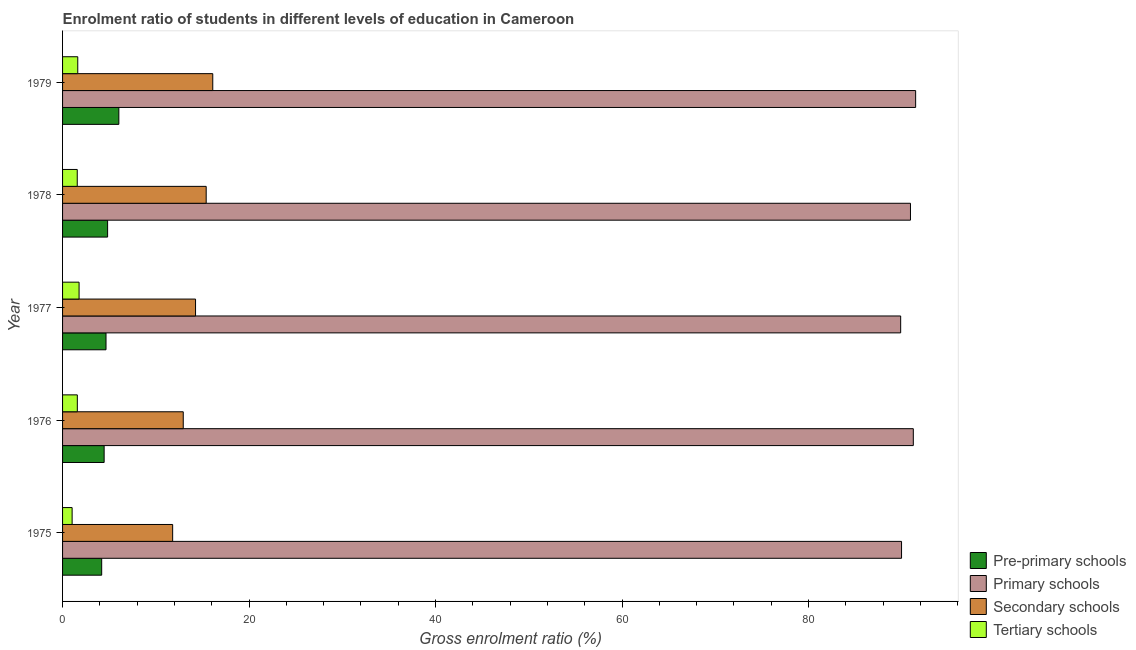How many groups of bars are there?
Provide a succinct answer. 5. Are the number of bars per tick equal to the number of legend labels?
Ensure brevity in your answer.  Yes. How many bars are there on the 4th tick from the top?
Offer a terse response. 4. What is the label of the 5th group of bars from the top?
Your answer should be very brief. 1975. In how many cases, is the number of bars for a given year not equal to the number of legend labels?
Ensure brevity in your answer.  0. What is the gross enrolment ratio in primary schools in 1977?
Your response must be concise. 89.88. Across all years, what is the maximum gross enrolment ratio in pre-primary schools?
Your response must be concise. 6.04. Across all years, what is the minimum gross enrolment ratio in primary schools?
Your answer should be very brief. 89.88. In which year was the gross enrolment ratio in pre-primary schools maximum?
Provide a succinct answer. 1979. In which year was the gross enrolment ratio in primary schools minimum?
Ensure brevity in your answer.  1977. What is the total gross enrolment ratio in secondary schools in the graph?
Provide a succinct answer. 70.52. What is the difference between the gross enrolment ratio in primary schools in 1977 and that in 1978?
Your answer should be very brief. -1.05. What is the difference between the gross enrolment ratio in primary schools in 1977 and the gross enrolment ratio in tertiary schools in 1975?
Your answer should be compact. 88.85. What is the average gross enrolment ratio in primary schools per year?
Provide a short and direct response. 90.7. In the year 1979, what is the difference between the gross enrolment ratio in primary schools and gross enrolment ratio in pre-primary schools?
Make the answer very short. 85.45. What is the ratio of the gross enrolment ratio in pre-primary schools in 1975 to that in 1977?
Ensure brevity in your answer.  0.9. What is the difference between the highest and the second highest gross enrolment ratio in primary schools?
Make the answer very short. 0.25. What is the difference between the highest and the lowest gross enrolment ratio in primary schools?
Provide a succinct answer. 1.61. In how many years, is the gross enrolment ratio in tertiary schools greater than the average gross enrolment ratio in tertiary schools taken over all years?
Offer a terse response. 4. Is it the case that in every year, the sum of the gross enrolment ratio in primary schools and gross enrolment ratio in pre-primary schools is greater than the sum of gross enrolment ratio in secondary schools and gross enrolment ratio in tertiary schools?
Your response must be concise. Yes. What does the 4th bar from the top in 1975 represents?
Your response must be concise. Pre-primary schools. What does the 3rd bar from the bottom in 1979 represents?
Make the answer very short. Secondary schools. Is it the case that in every year, the sum of the gross enrolment ratio in pre-primary schools and gross enrolment ratio in primary schools is greater than the gross enrolment ratio in secondary schools?
Offer a terse response. Yes. Are the values on the major ticks of X-axis written in scientific E-notation?
Your answer should be very brief. No. Where does the legend appear in the graph?
Provide a succinct answer. Bottom right. How many legend labels are there?
Offer a terse response. 4. How are the legend labels stacked?
Offer a very short reply. Vertical. What is the title of the graph?
Give a very brief answer. Enrolment ratio of students in different levels of education in Cameroon. What is the Gross enrolment ratio (%) of Pre-primary schools in 1975?
Offer a very short reply. 4.19. What is the Gross enrolment ratio (%) in Primary schools in 1975?
Provide a succinct answer. 89.97. What is the Gross enrolment ratio (%) of Secondary schools in 1975?
Keep it short and to the point. 11.81. What is the Gross enrolment ratio (%) in Tertiary schools in 1975?
Give a very brief answer. 1.03. What is the Gross enrolment ratio (%) of Pre-primary schools in 1976?
Your answer should be compact. 4.46. What is the Gross enrolment ratio (%) in Primary schools in 1976?
Offer a very short reply. 91.24. What is the Gross enrolment ratio (%) of Secondary schools in 1976?
Ensure brevity in your answer.  12.94. What is the Gross enrolment ratio (%) in Tertiary schools in 1976?
Provide a succinct answer. 1.58. What is the Gross enrolment ratio (%) in Pre-primary schools in 1977?
Give a very brief answer. 4.66. What is the Gross enrolment ratio (%) in Primary schools in 1977?
Give a very brief answer. 89.88. What is the Gross enrolment ratio (%) of Secondary schools in 1977?
Make the answer very short. 14.26. What is the Gross enrolment ratio (%) in Tertiary schools in 1977?
Offer a very short reply. 1.77. What is the Gross enrolment ratio (%) of Pre-primary schools in 1978?
Your answer should be very brief. 4.83. What is the Gross enrolment ratio (%) of Primary schools in 1978?
Keep it short and to the point. 90.93. What is the Gross enrolment ratio (%) of Secondary schools in 1978?
Offer a very short reply. 15.4. What is the Gross enrolment ratio (%) in Tertiary schools in 1978?
Offer a very short reply. 1.57. What is the Gross enrolment ratio (%) of Pre-primary schools in 1979?
Your response must be concise. 6.04. What is the Gross enrolment ratio (%) in Primary schools in 1979?
Provide a short and direct response. 91.48. What is the Gross enrolment ratio (%) in Secondary schools in 1979?
Provide a short and direct response. 16.11. What is the Gross enrolment ratio (%) of Tertiary schools in 1979?
Offer a very short reply. 1.63. Across all years, what is the maximum Gross enrolment ratio (%) of Pre-primary schools?
Make the answer very short. 6.04. Across all years, what is the maximum Gross enrolment ratio (%) of Primary schools?
Your answer should be very brief. 91.48. Across all years, what is the maximum Gross enrolment ratio (%) of Secondary schools?
Provide a succinct answer. 16.11. Across all years, what is the maximum Gross enrolment ratio (%) of Tertiary schools?
Your answer should be very brief. 1.77. Across all years, what is the minimum Gross enrolment ratio (%) of Pre-primary schools?
Offer a very short reply. 4.19. Across all years, what is the minimum Gross enrolment ratio (%) in Primary schools?
Offer a very short reply. 89.88. Across all years, what is the minimum Gross enrolment ratio (%) of Secondary schools?
Make the answer very short. 11.81. Across all years, what is the minimum Gross enrolment ratio (%) in Tertiary schools?
Make the answer very short. 1.03. What is the total Gross enrolment ratio (%) of Pre-primary schools in the graph?
Keep it short and to the point. 24.18. What is the total Gross enrolment ratio (%) in Primary schools in the graph?
Provide a short and direct response. 453.5. What is the total Gross enrolment ratio (%) in Secondary schools in the graph?
Offer a very short reply. 70.52. What is the total Gross enrolment ratio (%) of Tertiary schools in the graph?
Keep it short and to the point. 7.58. What is the difference between the Gross enrolment ratio (%) in Pre-primary schools in 1975 and that in 1976?
Ensure brevity in your answer.  -0.26. What is the difference between the Gross enrolment ratio (%) of Primary schools in 1975 and that in 1976?
Provide a succinct answer. -1.26. What is the difference between the Gross enrolment ratio (%) of Secondary schools in 1975 and that in 1976?
Your answer should be compact. -1.14. What is the difference between the Gross enrolment ratio (%) in Tertiary schools in 1975 and that in 1976?
Provide a succinct answer. -0.56. What is the difference between the Gross enrolment ratio (%) in Pre-primary schools in 1975 and that in 1977?
Offer a very short reply. -0.46. What is the difference between the Gross enrolment ratio (%) in Primary schools in 1975 and that in 1977?
Keep it short and to the point. 0.09. What is the difference between the Gross enrolment ratio (%) of Secondary schools in 1975 and that in 1977?
Your answer should be very brief. -2.45. What is the difference between the Gross enrolment ratio (%) in Tertiary schools in 1975 and that in 1977?
Your answer should be compact. -0.75. What is the difference between the Gross enrolment ratio (%) of Pre-primary schools in 1975 and that in 1978?
Your answer should be very brief. -0.64. What is the difference between the Gross enrolment ratio (%) in Primary schools in 1975 and that in 1978?
Ensure brevity in your answer.  -0.96. What is the difference between the Gross enrolment ratio (%) of Secondary schools in 1975 and that in 1978?
Provide a short and direct response. -3.59. What is the difference between the Gross enrolment ratio (%) in Tertiary schools in 1975 and that in 1978?
Give a very brief answer. -0.55. What is the difference between the Gross enrolment ratio (%) of Pre-primary schools in 1975 and that in 1979?
Give a very brief answer. -1.84. What is the difference between the Gross enrolment ratio (%) of Primary schools in 1975 and that in 1979?
Make the answer very short. -1.51. What is the difference between the Gross enrolment ratio (%) of Secondary schools in 1975 and that in 1979?
Ensure brevity in your answer.  -4.3. What is the difference between the Gross enrolment ratio (%) in Tertiary schools in 1975 and that in 1979?
Ensure brevity in your answer.  -0.61. What is the difference between the Gross enrolment ratio (%) in Pre-primary schools in 1976 and that in 1977?
Provide a short and direct response. -0.2. What is the difference between the Gross enrolment ratio (%) of Primary schools in 1976 and that in 1977?
Make the answer very short. 1.36. What is the difference between the Gross enrolment ratio (%) in Secondary schools in 1976 and that in 1977?
Give a very brief answer. -1.32. What is the difference between the Gross enrolment ratio (%) of Tertiary schools in 1976 and that in 1977?
Your answer should be very brief. -0.19. What is the difference between the Gross enrolment ratio (%) in Pre-primary schools in 1976 and that in 1978?
Provide a short and direct response. -0.37. What is the difference between the Gross enrolment ratio (%) of Primary schools in 1976 and that in 1978?
Offer a very short reply. 0.3. What is the difference between the Gross enrolment ratio (%) of Secondary schools in 1976 and that in 1978?
Ensure brevity in your answer.  -2.46. What is the difference between the Gross enrolment ratio (%) in Tertiary schools in 1976 and that in 1978?
Give a very brief answer. 0.01. What is the difference between the Gross enrolment ratio (%) in Pre-primary schools in 1976 and that in 1979?
Your answer should be compact. -1.58. What is the difference between the Gross enrolment ratio (%) of Primary schools in 1976 and that in 1979?
Keep it short and to the point. -0.25. What is the difference between the Gross enrolment ratio (%) of Secondary schools in 1976 and that in 1979?
Your response must be concise. -3.17. What is the difference between the Gross enrolment ratio (%) of Tertiary schools in 1976 and that in 1979?
Your response must be concise. -0.05. What is the difference between the Gross enrolment ratio (%) of Pre-primary schools in 1977 and that in 1978?
Provide a short and direct response. -0.17. What is the difference between the Gross enrolment ratio (%) in Primary schools in 1977 and that in 1978?
Your answer should be very brief. -1.05. What is the difference between the Gross enrolment ratio (%) in Secondary schools in 1977 and that in 1978?
Your answer should be very brief. -1.14. What is the difference between the Gross enrolment ratio (%) in Tertiary schools in 1977 and that in 1978?
Ensure brevity in your answer.  0.2. What is the difference between the Gross enrolment ratio (%) in Pre-primary schools in 1977 and that in 1979?
Offer a terse response. -1.38. What is the difference between the Gross enrolment ratio (%) of Primary schools in 1977 and that in 1979?
Ensure brevity in your answer.  -1.61. What is the difference between the Gross enrolment ratio (%) in Secondary schools in 1977 and that in 1979?
Your response must be concise. -1.85. What is the difference between the Gross enrolment ratio (%) of Tertiary schools in 1977 and that in 1979?
Ensure brevity in your answer.  0.14. What is the difference between the Gross enrolment ratio (%) of Pre-primary schools in 1978 and that in 1979?
Ensure brevity in your answer.  -1.2. What is the difference between the Gross enrolment ratio (%) in Primary schools in 1978 and that in 1979?
Offer a very short reply. -0.55. What is the difference between the Gross enrolment ratio (%) of Secondary schools in 1978 and that in 1979?
Provide a short and direct response. -0.71. What is the difference between the Gross enrolment ratio (%) of Tertiary schools in 1978 and that in 1979?
Your answer should be very brief. -0.06. What is the difference between the Gross enrolment ratio (%) in Pre-primary schools in 1975 and the Gross enrolment ratio (%) in Primary schools in 1976?
Your answer should be very brief. -87.04. What is the difference between the Gross enrolment ratio (%) of Pre-primary schools in 1975 and the Gross enrolment ratio (%) of Secondary schools in 1976?
Offer a terse response. -8.75. What is the difference between the Gross enrolment ratio (%) of Pre-primary schools in 1975 and the Gross enrolment ratio (%) of Tertiary schools in 1976?
Your answer should be very brief. 2.61. What is the difference between the Gross enrolment ratio (%) in Primary schools in 1975 and the Gross enrolment ratio (%) in Secondary schools in 1976?
Your answer should be very brief. 77.03. What is the difference between the Gross enrolment ratio (%) of Primary schools in 1975 and the Gross enrolment ratio (%) of Tertiary schools in 1976?
Provide a short and direct response. 88.39. What is the difference between the Gross enrolment ratio (%) of Secondary schools in 1975 and the Gross enrolment ratio (%) of Tertiary schools in 1976?
Make the answer very short. 10.22. What is the difference between the Gross enrolment ratio (%) of Pre-primary schools in 1975 and the Gross enrolment ratio (%) of Primary schools in 1977?
Give a very brief answer. -85.68. What is the difference between the Gross enrolment ratio (%) of Pre-primary schools in 1975 and the Gross enrolment ratio (%) of Secondary schools in 1977?
Give a very brief answer. -10.07. What is the difference between the Gross enrolment ratio (%) of Pre-primary schools in 1975 and the Gross enrolment ratio (%) of Tertiary schools in 1977?
Give a very brief answer. 2.42. What is the difference between the Gross enrolment ratio (%) of Primary schools in 1975 and the Gross enrolment ratio (%) of Secondary schools in 1977?
Offer a very short reply. 75.71. What is the difference between the Gross enrolment ratio (%) in Primary schools in 1975 and the Gross enrolment ratio (%) in Tertiary schools in 1977?
Offer a terse response. 88.2. What is the difference between the Gross enrolment ratio (%) in Secondary schools in 1975 and the Gross enrolment ratio (%) in Tertiary schools in 1977?
Your answer should be very brief. 10.04. What is the difference between the Gross enrolment ratio (%) in Pre-primary schools in 1975 and the Gross enrolment ratio (%) in Primary schools in 1978?
Provide a succinct answer. -86.74. What is the difference between the Gross enrolment ratio (%) in Pre-primary schools in 1975 and the Gross enrolment ratio (%) in Secondary schools in 1978?
Your response must be concise. -11.21. What is the difference between the Gross enrolment ratio (%) in Pre-primary schools in 1975 and the Gross enrolment ratio (%) in Tertiary schools in 1978?
Give a very brief answer. 2.62. What is the difference between the Gross enrolment ratio (%) in Primary schools in 1975 and the Gross enrolment ratio (%) in Secondary schools in 1978?
Ensure brevity in your answer.  74.57. What is the difference between the Gross enrolment ratio (%) of Primary schools in 1975 and the Gross enrolment ratio (%) of Tertiary schools in 1978?
Provide a succinct answer. 88.4. What is the difference between the Gross enrolment ratio (%) in Secondary schools in 1975 and the Gross enrolment ratio (%) in Tertiary schools in 1978?
Your answer should be compact. 10.23. What is the difference between the Gross enrolment ratio (%) of Pre-primary schools in 1975 and the Gross enrolment ratio (%) of Primary schools in 1979?
Ensure brevity in your answer.  -87.29. What is the difference between the Gross enrolment ratio (%) in Pre-primary schools in 1975 and the Gross enrolment ratio (%) in Secondary schools in 1979?
Your answer should be compact. -11.91. What is the difference between the Gross enrolment ratio (%) in Pre-primary schools in 1975 and the Gross enrolment ratio (%) in Tertiary schools in 1979?
Provide a succinct answer. 2.56. What is the difference between the Gross enrolment ratio (%) of Primary schools in 1975 and the Gross enrolment ratio (%) of Secondary schools in 1979?
Offer a terse response. 73.86. What is the difference between the Gross enrolment ratio (%) in Primary schools in 1975 and the Gross enrolment ratio (%) in Tertiary schools in 1979?
Offer a very short reply. 88.34. What is the difference between the Gross enrolment ratio (%) in Secondary schools in 1975 and the Gross enrolment ratio (%) in Tertiary schools in 1979?
Give a very brief answer. 10.18. What is the difference between the Gross enrolment ratio (%) in Pre-primary schools in 1976 and the Gross enrolment ratio (%) in Primary schools in 1977?
Provide a succinct answer. -85.42. What is the difference between the Gross enrolment ratio (%) in Pre-primary schools in 1976 and the Gross enrolment ratio (%) in Secondary schools in 1977?
Make the answer very short. -9.8. What is the difference between the Gross enrolment ratio (%) of Pre-primary schools in 1976 and the Gross enrolment ratio (%) of Tertiary schools in 1977?
Provide a short and direct response. 2.69. What is the difference between the Gross enrolment ratio (%) in Primary schools in 1976 and the Gross enrolment ratio (%) in Secondary schools in 1977?
Offer a terse response. 76.97. What is the difference between the Gross enrolment ratio (%) in Primary schools in 1976 and the Gross enrolment ratio (%) in Tertiary schools in 1977?
Provide a short and direct response. 89.46. What is the difference between the Gross enrolment ratio (%) in Secondary schools in 1976 and the Gross enrolment ratio (%) in Tertiary schools in 1977?
Your response must be concise. 11.17. What is the difference between the Gross enrolment ratio (%) of Pre-primary schools in 1976 and the Gross enrolment ratio (%) of Primary schools in 1978?
Make the answer very short. -86.47. What is the difference between the Gross enrolment ratio (%) in Pre-primary schools in 1976 and the Gross enrolment ratio (%) in Secondary schools in 1978?
Ensure brevity in your answer.  -10.94. What is the difference between the Gross enrolment ratio (%) of Pre-primary schools in 1976 and the Gross enrolment ratio (%) of Tertiary schools in 1978?
Give a very brief answer. 2.88. What is the difference between the Gross enrolment ratio (%) of Primary schools in 1976 and the Gross enrolment ratio (%) of Secondary schools in 1978?
Your answer should be very brief. 75.83. What is the difference between the Gross enrolment ratio (%) in Primary schools in 1976 and the Gross enrolment ratio (%) in Tertiary schools in 1978?
Provide a succinct answer. 89.66. What is the difference between the Gross enrolment ratio (%) in Secondary schools in 1976 and the Gross enrolment ratio (%) in Tertiary schools in 1978?
Your response must be concise. 11.37. What is the difference between the Gross enrolment ratio (%) in Pre-primary schools in 1976 and the Gross enrolment ratio (%) in Primary schools in 1979?
Your answer should be very brief. -87.03. What is the difference between the Gross enrolment ratio (%) of Pre-primary schools in 1976 and the Gross enrolment ratio (%) of Secondary schools in 1979?
Give a very brief answer. -11.65. What is the difference between the Gross enrolment ratio (%) in Pre-primary schools in 1976 and the Gross enrolment ratio (%) in Tertiary schools in 1979?
Offer a very short reply. 2.83. What is the difference between the Gross enrolment ratio (%) of Primary schools in 1976 and the Gross enrolment ratio (%) of Secondary schools in 1979?
Your answer should be very brief. 75.13. What is the difference between the Gross enrolment ratio (%) of Primary schools in 1976 and the Gross enrolment ratio (%) of Tertiary schools in 1979?
Give a very brief answer. 89.6. What is the difference between the Gross enrolment ratio (%) in Secondary schools in 1976 and the Gross enrolment ratio (%) in Tertiary schools in 1979?
Your response must be concise. 11.31. What is the difference between the Gross enrolment ratio (%) in Pre-primary schools in 1977 and the Gross enrolment ratio (%) in Primary schools in 1978?
Ensure brevity in your answer.  -86.27. What is the difference between the Gross enrolment ratio (%) of Pre-primary schools in 1977 and the Gross enrolment ratio (%) of Secondary schools in 1978?
Ensure brevity in your answer.  -10.74. What is the difference between the Gross enrolment ratio (%) in Pre-primary schools in 1977 and the Gross enrolment ratio (%) in Tertiary schools in 1978?
Your answer should be compact. 3.08. What is the difference between the Gross enrolment ratio (%) of Primary schools in 1977 and the Gross enrolment ratio (%) of Secondary schools in 1978?
Your answer should be very brief. 74.48. What is the difference between the Gross enrolment ratio (%) in Primary schools in 1977 and the Gross enrolment ratio (%) in Tertiary schools in 1978?
Provide a succinct answer. 88.3. What is the difference between the Gross enrolment ratio (%) of Secondary schools in 1977 and the Gross enrolment ratio (%) of Tertiary schools in 1978?
Give a very brief answer. 12.69. What is the difference between the Gross enrolment ratio (%) in Pre-primary schools in 1977 and the Gross enrolment ratio (%) in Primary schools in 1979?
Give a very brief answer. -86.83. What is the difference between the Gross enrolment ratio (%) in Pre-primary schools in 1977 and the Gross enrolment ratio (%) in Secondary schools in 1979?
Your answer should be compact. -11.45. What is the difference between the Gross enrolment ratio (%) in Pre-primary schools in 1977 and the Gross enrolment ratio (%) in Tertiary schools in 1979?
Offer a terse response. 3.03. What is the difference between the Gross enrolment ratio (%) of Primary schools in 1977 and the Gross enrolment ratio (%) of Secondary schools in 1979?
Offer a very short reply. 73.77. What is the difference between the Gross enrolment ratio (%) of Primary schools in 1977 and the Gross enrolment ratio (%) of Tertiary schools in 1979?
Ensure brevity in your answer.  88.25. What is the difference between the Gross enrolment ratio (%) of Secondary schools in 1977 and the Gross enrolment ratio (%) of Tertiary schools in 1979?
Offer a terse response. 12.63. What is the difference between the Gross enrolment ratio (%) of Pre-primary schools in 1978 and the Gross enrolment ratio (%) of Primary schools in 1979?
Make the answer very short. -86.65. What is the difference between the Gross enrolment ratio (%) of Pre-primary schools in 1978 and the Gross enrolment ratio (%) of Secondary schools in 1979?
Your answer should be very brief. -11.28. What is the difference between the Gross enrolment ratio (%) in Pre-primary schools in 1978 and the Gross enrolment ratio (%) in Tertiary schools in 1979?
Your answer should be very brief. 3.2. What is the difference between the Gross enrolment ratio (%) in Primary schools in 1978 and the Gross enrolment ratio (%) in Secondary schools in 1979?
Keep it short and to the point. 74.82. What is the difference between the Gross enrolment ratio (%) in Primary schools in 1978 and the Gross enrolment ratio (%) in Tertiary schools in 1979?
Provide a short and direct response. 89.3. What is the difference between the Gross enrolment ratio (%) in Secondary schools in 1978 and the Gross enrolment ratio (%) in Tertiary schools in 1979?
Your response must be concise. 13.77. What is the average Gross enrolment ratio (%) in Pre-primary schools per year?
Offer a very short reply. 4.84. What is the average Gross enrolment ratio (%) of Primary schools per year?
Your answer should be very brief. 90.7. What is the average Gross enrolment ratio (%) in Secondary schools per year?
Provide a short and direct response. 14.1. What is the average Gross enrolment ratio (%) of Tertiary schools per year?
Offer a terse response. 1.52. In the year 1975, what is the difference between the Gross enrolment ratio (%) of Pre-primary schools and Gross enrolment ratio (%) of Primary schools?
Provide a short and direct response. -85.78. In the year 1975, what is the difference between the Gross enrolment ratio (%) of Pre-primary schools and Gross enrolment ratio (%) of Secondary schools?
Ensure brevity in your answer.  -7.61. In the year 1975, what is the difference between the Gross enrolment ratio (%) in Pre-primary schools and Gross enrolment ratio (%) in Tertiary schools?
Your answer should be very brief. 3.17. In the year 1975, what is the difference between the Gross enrolment ratio (%) of Primary schools and Gross enrolment ratio (%) of Secondary schools?
Your answer should be very brief. 78.17. In the year 1975, what is the difference between the Gross enrolment ratio (%) of Primary schools and Gross enrolment ratio (%) of Tertiary schools?
Make the answer very short. 88.95. In the year 1975, what is the difference between the Gross enrolment ratio (%) of Secondary schools and Gross enrolment ratio (%) of Tertiary schools?
Offer a terse response. 10.78. In the year 1976, what is the difference between the Gross enrolment ratio (%) in Pre-primary schools and Gross enrolment ratio (%) in Primary schools?
Your answer should be very brief. -86.78. In the year 1976, what is the difference between the Gross enrolment ratio (%) in Pre-primary schools and Gross enrolment ratio (%) in Secondary schools?
Give a very brief answer. -8.48. In the year 1976, what is the difference between the Gross enrolment ratio (%) of Pre-primary schools and Gross enrolment ratio (%) of Tertiary schools?
Provide a short and direct response. 2.88. In the year 1976, what is the difference between the Gross enrolment ratio (%) in Primary schools and Gross enrolment ratio (%) in Secondary schools?
Offer a terse response. 78.29. In the year 1976, what is the difference between the Gross enrolment ratio (%) in Primary schools and Gross enrolment ratio (%) in Tertiary schools?
Provide a succinct answer. 89.65. In the year 1976, what is the difference between the Gross enrolment ratio (%) in Secondary schools and Gross enrolment ratio (%) in Tertiary schools?
Your response must be concise. 11.36. In the year 1977, what is the difference between the Gross enrolment ratio (%) in Pre-primary schools and Gross enrolment ratio (%) in Primary schools?
Provide a succinct answer. -85.22. In the year 1977, what is the difference between the Gross enrolment ratio (%) of Pre-primary schools and Gross enrolment ratio (%) of Secondary schools?
Offer a very short reply. -9.6. In the year 1977, what is the difference between the Gross enrolment ratio (%) in Pre-primary schools and Gross enrolment ratio (%) in Tertiary schools?
Your response must be concise. 2.89. In the year 1977, what is the difference between the Gross enrolment ratio (%) of Primary schools and Gross enrolment ratio (%) of Secondary schools?
Your answer should be very brief. 75.62. In the year 1977, what is the difference between the Gross enrolment ratio (%) in Primary schools and Gross enrolment ratio (%) in Tertiary schools?
Your response must be concise. 88.11. In the year 1977, what is the difference between the Gross enrolment ratio (%) of Secondary schools and Gross enrolment ratio (%) of Tertiary schools?
Offer a terse response. 12.49. In the year 1978, what is the difference between the Gross enrolment ratio (%) in Pre-primary schools and Gross enrolment ratio (%) in Primary schools?
Your response must be concise. -86.1. In the year 1978, what is the difference between the Gross enrolment ratio (%) in Pre-primary schools and Gross enrolment ratio (%) in Secondary schools?
Provide a succinct answer. -10.57. In the year 1978, what is the difference between the Gross enrolment ratio (%) of Pre-primary schools and Gross enrolment ratio (%) of Tertiary schools?
Offer a terse response. 3.26. In the year 1978, what is the difference between the Gross enrolment ratio (%) in Primary schools and Gross enrolment ratio (%) in Secondary schools?
Provide a short and direct response. 75.53. In the year 1978, what is the difference between the Gross enrolment ratio (%) in Primary schools and Gross enrolment ratio (%) in Tertiary schools?
Your response must be concise. 89.36. In the year 1978, what is the difference between the Gross enrolment ratio (%) in Secondary schools and Gross enrolment ratio (%) in Tertiary schools?
Your answer should be compact. 13.83. In the year 1979, what is the difference between the Gross enrolment ratio (%) of Pre-primary schools and Gross enrolment ratio (%) of Primary schools?
Make the answer very short. -85.45. In the year 1979, what is the difference between the Gross enrolment ratio (%) in Pre-primary schools and Gross enrolment ratio (%) in Secondary schools?
Your answer should be very brief. -10.07. In the year 1979, what is the difference between the Gross enrolment ratio (%) in Pre-primary schools and Gross enrolment ratio (%) in Tertiary schools?
Provide a succinct answer. 4.4. In the year 1979, what is the difference between the Gross enrolment ratio (%) of Primary schools and Gross enrolment ratio (%) of Secondary schools?
Your answer should be very brief. 75.38. In the year 1979, what is the difference between the Gross enrolment ratio (%) of Primary schools and Gross enrolment ratio (%) of Tertiary schools?
Provide a succinct answer. 89.85. In the year 1979, what is the difference between the Gross enrolment ratio (%) of Secondary schools and Gross enrolment ratio (%) of Tertiary schools?
Provide a succinct answer. 14.48. What is the ratio of the Gross enrolment ratio (%) in Pre-primary schools in 1975 to that in 1976?
Your answer should be compact. 0.94. What is the ratio of the Gross enrolment ratio (%) in Primary schools in 1975 to that in 1976?
Offer a terse response. 0.99. What is the ratio of the Gross enrolment ratio (%) in Secondary schools in 1975 to that in 1976?
Your answer should be compact. 0.91. What is the ratio of the Gross enrolment ratio (%) of Tertiary schools in 1975 to that in 1976?
Give a very brief answer. 0.65. What is the ratio of the Gross enrolment ratio (%) in Pre-primary schools in 1975 to that in 1977?
Provide a short and direct response. 0.9. What is the ratio of the Gross enrolment ratio (%) of Secondary schools in 1975 to that in 1977?
Ensure brevity in your answer.  0.83. What is the ratio of the Gross enrolment ratio (%) of Tertiary schools in 1975 to that in 1977?
Ensure brevity in your answer.  0.58. What is the ratio of the Gross enrolment ratio (%) of Pre-primary schools in 1975 to that in 1978?
Ensure brevity in your answer.  0.87. What is the ratio of the Gross enrolment ratio (%) in Primary schools in 1975 to that in 1978?
Give a very brief answer. 0.99. What is the ratio of the Gross enrolment ratio (%) in Secondary schools in 1975 to that in 1978?
Your answer should be compact. 0.77. What is the ratio of the Gross enrolment ratio (%) in Tertiary schools in 1975 to that in 1978?
Keep it short and to the point. 0.65. What is the ratio of the Gross enrolment ratio (%) in Pre-primary schools in 1975 to that in 1979?
Provide a succinct answer. 0.7. What is the ratio of the Gross enrolment ratio (%) of Primary schools in 1975 to that in 1979?
Make the answer very short. 0.98. What is the ratio of the Gross enrolment ratio (%) in Secondary schools in 1975 to that in 1979?
Make the answer very short. 0.73. What is the ratio of the Gross enrolment ratio (%) of Tertiary schools in 1975 to that in 1979?
Offer a terse response. 0.63. What is the ratio of the Gross enrolment ratio (%) of Pre-primary schools in 1976 to that in 1977?
Provide a short and direct response. 0.96. What is the ratio of the Gross enrolment ratio (%) in Primary schools in 1976 to that in 1977?
Keep it short and to the point. 1.02. What is the ratio of the Gross enrolment ratio (%) of Secondary schools in 1976 to that in 1977?
Provide a short and direct response. 0.91. What is the ratio of the Gross enrolment ratio (%) of Tertiary schools in 1976 to that in 1977?
Make the answer very short. 0.89. What is the ratio of the Gross enrolment ratio (%) of Pre-primary schools in 1976 to that in 1978?
Offer a very short reply. 0.92. What is the ratio of the Gross enrolment ratio (%) of Secondary schools in 1976 to that in 1978?
Give a very brief answer. 0.84. What is the ratio of the Gross enrolment ratio (%) in Pre-primary schools in 1976 to that in 1979?
Make the answer very short. 0.74. What is the ratio of the Gross enrolment ratio (%) in Secondary schools in 1976 to that in 1979?
Your response must be concise. 0.8. What is the ratio of the Gross enrolment ratio (%) of Tertiary schools in 1976 to that in 1979?
Give a very brief answer. 0.97. What is the ratio of the Gross enrolment ratio (%) in Pre-primary schools in 1977 to that in 1978?
Your response must be concise. 0.96. What is the ratio of the Gross enrolment ratio (%) of Primary schools in 1977 to that in 1978?
Offer a terse response. 0.99. What is the ratio of the Gross enrolment ratio (%) of Secondary schools in 1977 to that in 1978?
Make the answer very short. 0.93. What is the ratio of the Gross enrolment ratio (%) in Tertiary schools in 1977 to that in 1978?
Keep it short and to the point. 1.12. What is the ratio of the Gross enrolment ratio (%) of Pre-primary schools in 1977 to that in 1979?
Your response must be concise. 0.77. What is the ratio of the Gross enrolment ratio (%) of Primary schools in 1977 to that in 1979?
Your answer should be very brief. 0.98. What is the ratio of the Gross enrolment ratio (%) of Secondary schools in 1977 to that in 1979?
Your response must be concise. 0.89. What is the ratio of the Gross enrolment ratio (%) of Tertiary schools in 1977 to that in 1979?
Give a very brief answer. 1.09. What is the ratio of the Gross enrolment ratio (%) of Pre-primary schools in 1978 to that in 1979?
Provide a succinct answer. 0.8. What is the ratio of the Gross enrolment ratio (%) of Primary schools in 1978 to that in 1979?
Make the answer very short. 0.99. What is the ratio of the Gross enrolment ratio (%) of Secondary schools in 1978 to that in 1979?
Your response must be concise. 0.96. What is the ratio of the Gross enrolment ratio (%) in Tertiary schools in 1978 to that in 1979?
Your answer should be very brief. 0.97. What is the difference between the highest and the second highest Gross enrolment ratio (%) of Pre-primary schools?
Offer a very short reply. 1.2. What is the difference between the highest and the second highest Gross enrolment ratio (%) of Primary schools?
Your answer should be compact. 0.25. What is the difference between the highest and the second highest Gross enrolment ratio (%) in Secondary schools?
Ensure brevity in your answer.  0.71. What is the difference between the highest and the second highest Gross enrolment ratio (%) in Tertiary schools?
Ensure brevity in your answer.  0.14. What is the difference between the highest and the lowest Gross enrolment ratio (%) in Pre-primary schools?
Offer a very short reply. 1.84. What is the difference between the highest and the lowest Gross enrolment ratio (%) in Primary schools?
Give a very brief answer. 1.61. What is the difference between the highest and the lowest Gross enrolment ratio (%) in Secondary schools?
Provide a short and direct response. 4.3. What is the difference between the highest and the lowest Gross enrolment ratio (%) of Tertiary schools?
Your answer should be compact. 0.75. 